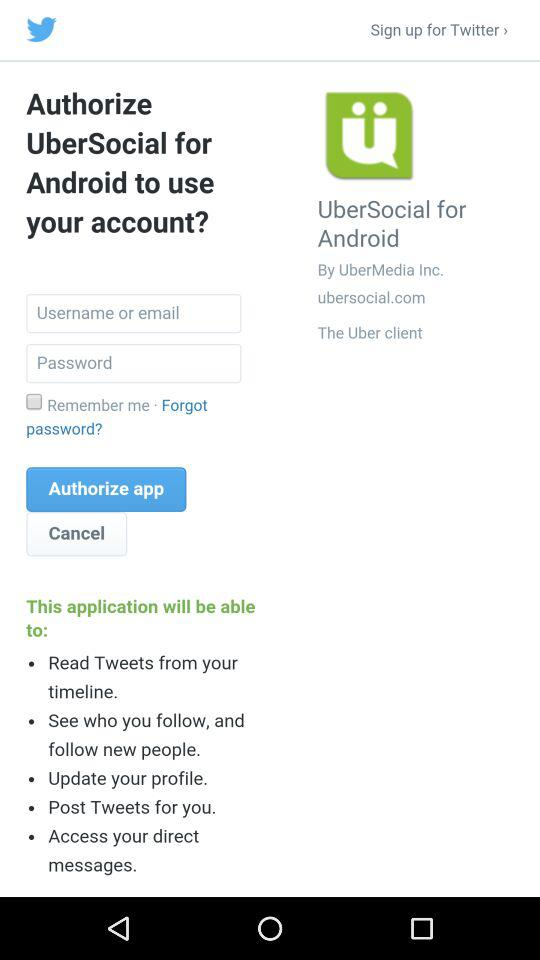How many characters are required to create a password?
When the provided information is insufficient, respond with <no answer>. <no answer> 